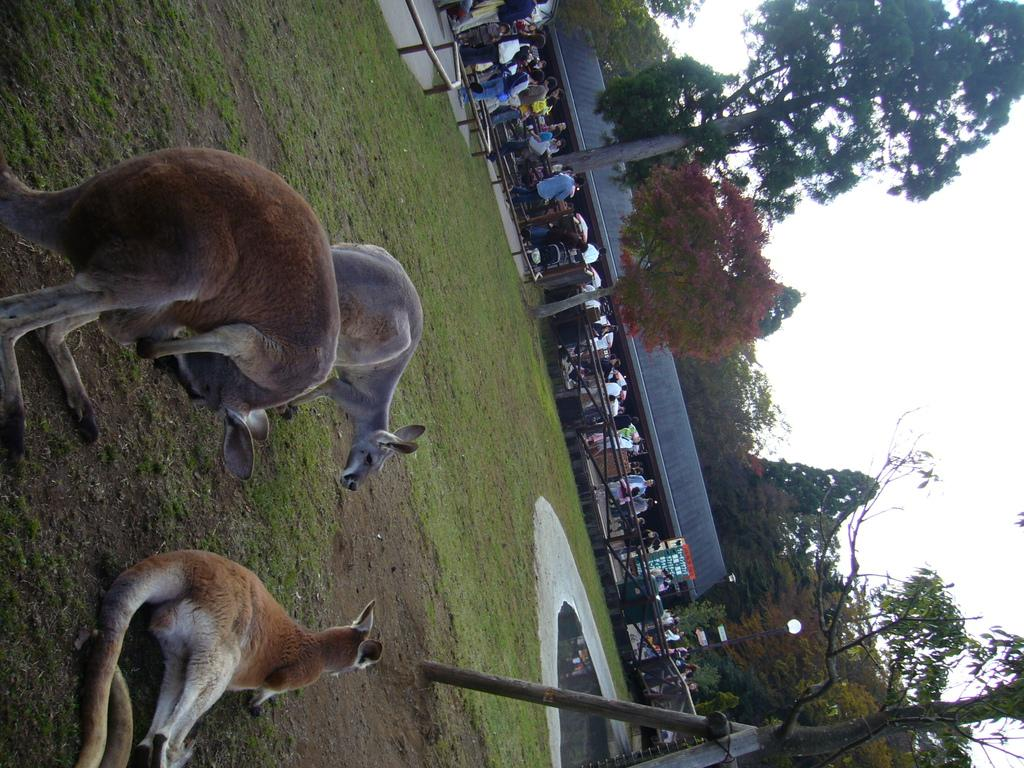How many people are in the image? There are people in the image, but the exact number is not specified. What type of animals can be seen in the image? There are three animals in the image. What natural elements are present in the image? There are trees in the image. What man-made structures can be seen in the image? There are poles, fencing, a shed, and a light pole in the image. What part of the natural environment is visible in the image? The sky is visible in the image. What type of insurance policy is being discussed by the people in the image? There is no indication in the image that the people are discussing any insurance policies. Can you tell me how many ants are crawling on the animals in the image? There are no ants present in the image. 